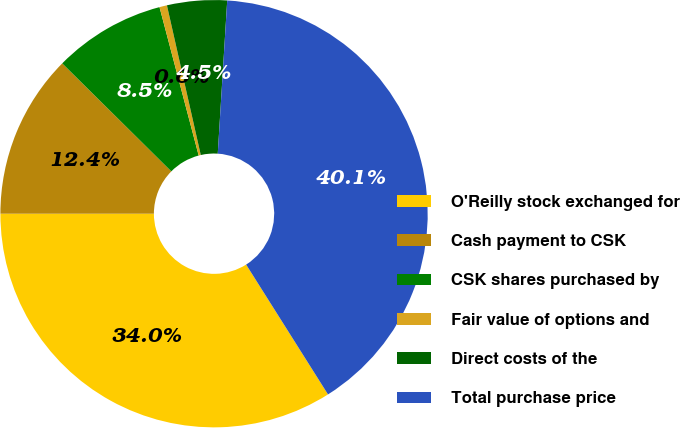<chart> <loc_0><loc_0><loc_500><loc_500><pie_chart><fcel>O'Reilly stock exchanged for<fcel>Cash payment to CSK<fcel>CSK shares purchased by<fcel>Fair value of options and<fcel>Direct costs of the<fcel>Total purchase price<nl><fcel>33.95%<fcel>12.42%<fcel>8.47%<fcel>0.57%<fcel>4.52%<fcel>40.06%<nl></chart> 